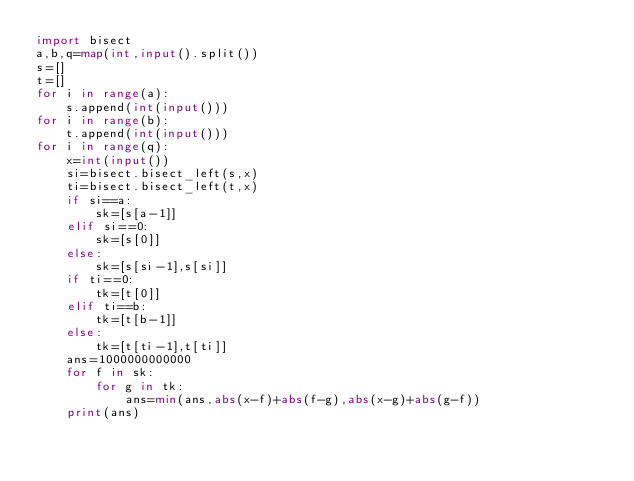<code> <loc_0><loc_0><loc_500><loc_500><_Python_>import bisect
a,b,q=map(int,input().split())
s=[]
t=[]
for i in range(a):
    s.append(int(input()))
for i in range(b):
    t.append(int(input()))
for i in range(q):
    x=int(input())
    si=bisect.bisect_left(s,x)
    ti=bisect.bisect_left(t,x)
    if si==a:
        sk=[s[a-1]]
    elif si==0:
        sk=[s[0]]
    else:
        sk=[s[si-1],s[si]]
    if ti==0:
        tk=[t[0]]
    elif ti==b:
        tk=[t[b-1]]
    else:
        tk=[t[ti-1],t[ti]]
    ans=1000000000000
    for f in sk:
        for g in tk:
            ans=min(ans,abs(x-f)+abs(f-g),abs(x-g)+abs(g-f))
    print(ans)
</code> 